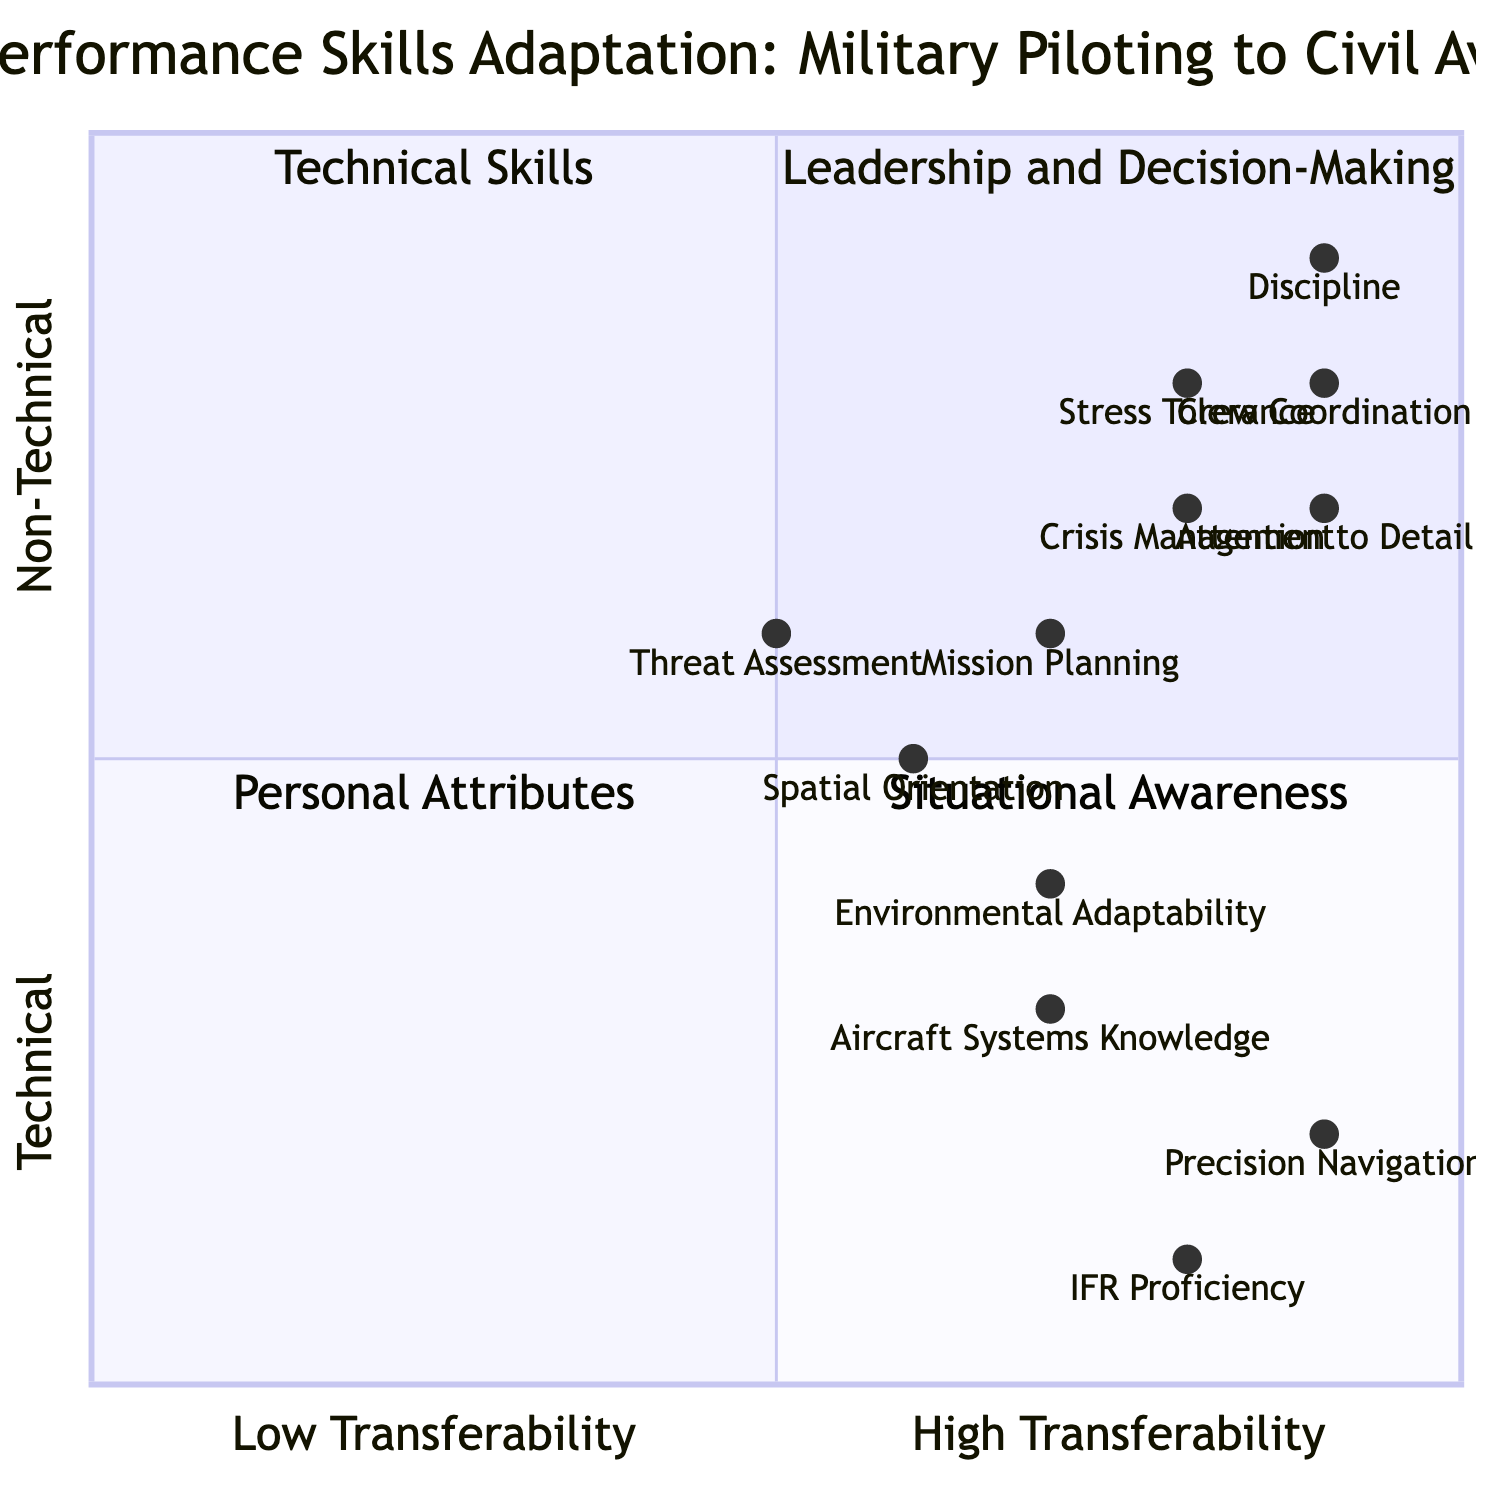What quadrant contains Crew Coordination? Crew Coordination is located in the "Leadership and Decision-Making" quadrant, which is positioned in the upper-left section of the diagram.
Answer: Leadership and Decision-Making Which skill has the highest level of technical transferability? Precision Navigation has a transferability value of 0.9, indicating it has the highest level of technical transferability among the listed skills.
Answer: Precision Navigation How many skills are categorized as Personal Attributes? There are three skills listed under "Personal Attributes": Discipline, Stress Tolerance, and Attention to Detail. Therefore, the total is three.
Answer: 3 What is the transferability score of Threat Assessment? Threat Assessment has a transferability score of 0.5 based on its position in the quadrant, indicating a moderate level of transferability.
Answer: 0.5 Which skill has the lowest transferability rating in the Technical Skills quadrant? Among the skills in the Technical Skills quadrant, Aircraft Systems Knowledge has the lowest transferability rating at 0.7.
Answer: Aircraft Systems Knowledge Which two skills have the same transferability score of 0.8? The skills Crisis Management and Stress Tolerance both have a transferability score of 0.8, indicating they share this rating.
Answer: 0.8 What is the relationship between Spatial Orientation and Environmental Adaptability in terms of transferability? Spatial Orientation has a score of 0.6, whereas Environmental Adaptability has a score of 0.7. Thus, Environmental Adaptability has a higher transferability score than Spatial Orientation.
Answer: Higher Which quadrant has the skill with the highest personal attributes rating? The skill with the highest rating, Discipline, is in the Personal Attributes quadrant, where it has a rating of 0.9.
Answer: Personal Attributes What is the average transferability score of all skills in the Leadership and Decision-Making quadrant? The scores for Crisis Management, Mission Planning, and Crew Coordination are 0.8, 0.7, and 0.9 respectively. The average is (0.8 + 0.7 + 0.9) / 3 = 0.8.
Answer: 0.8 